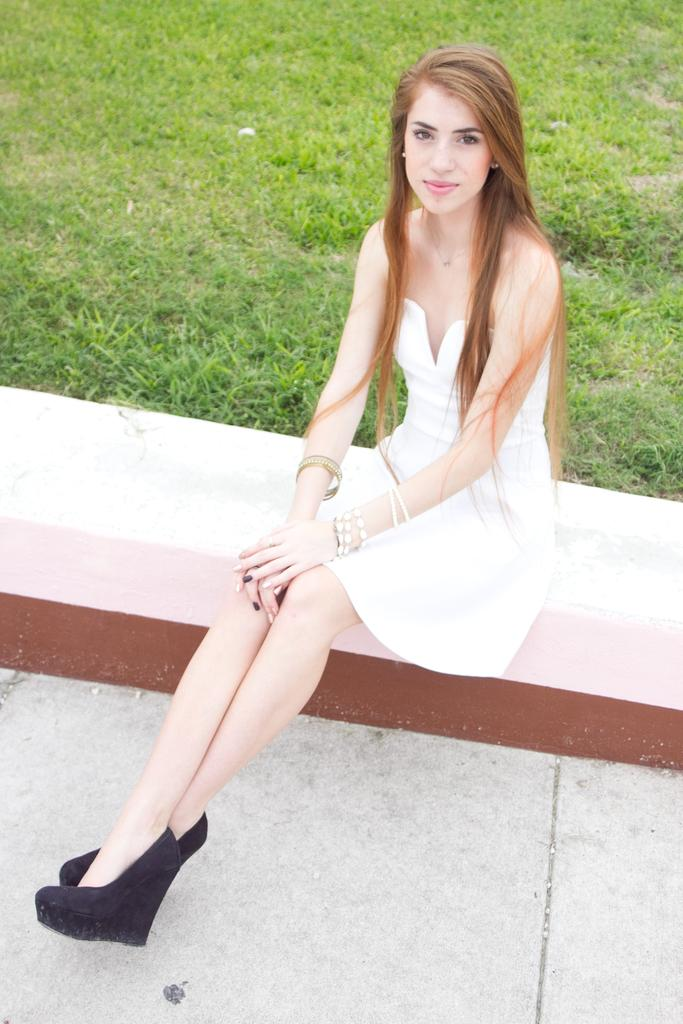What is the appearance of the woman in the image? There is a beautiful woman in the image. What is the woman wearing? The woman is wearing a white dress. What is the woman doing in the image? The woman is sitting on a bench. What type of surface is visible beneath the woman? There is floor visible in the image. What can be seen in the background of the image? There is grass in the background of the image. How many branches are visible on the lamp in the image? There is no lamp present in the image, so there are no branches to count. 